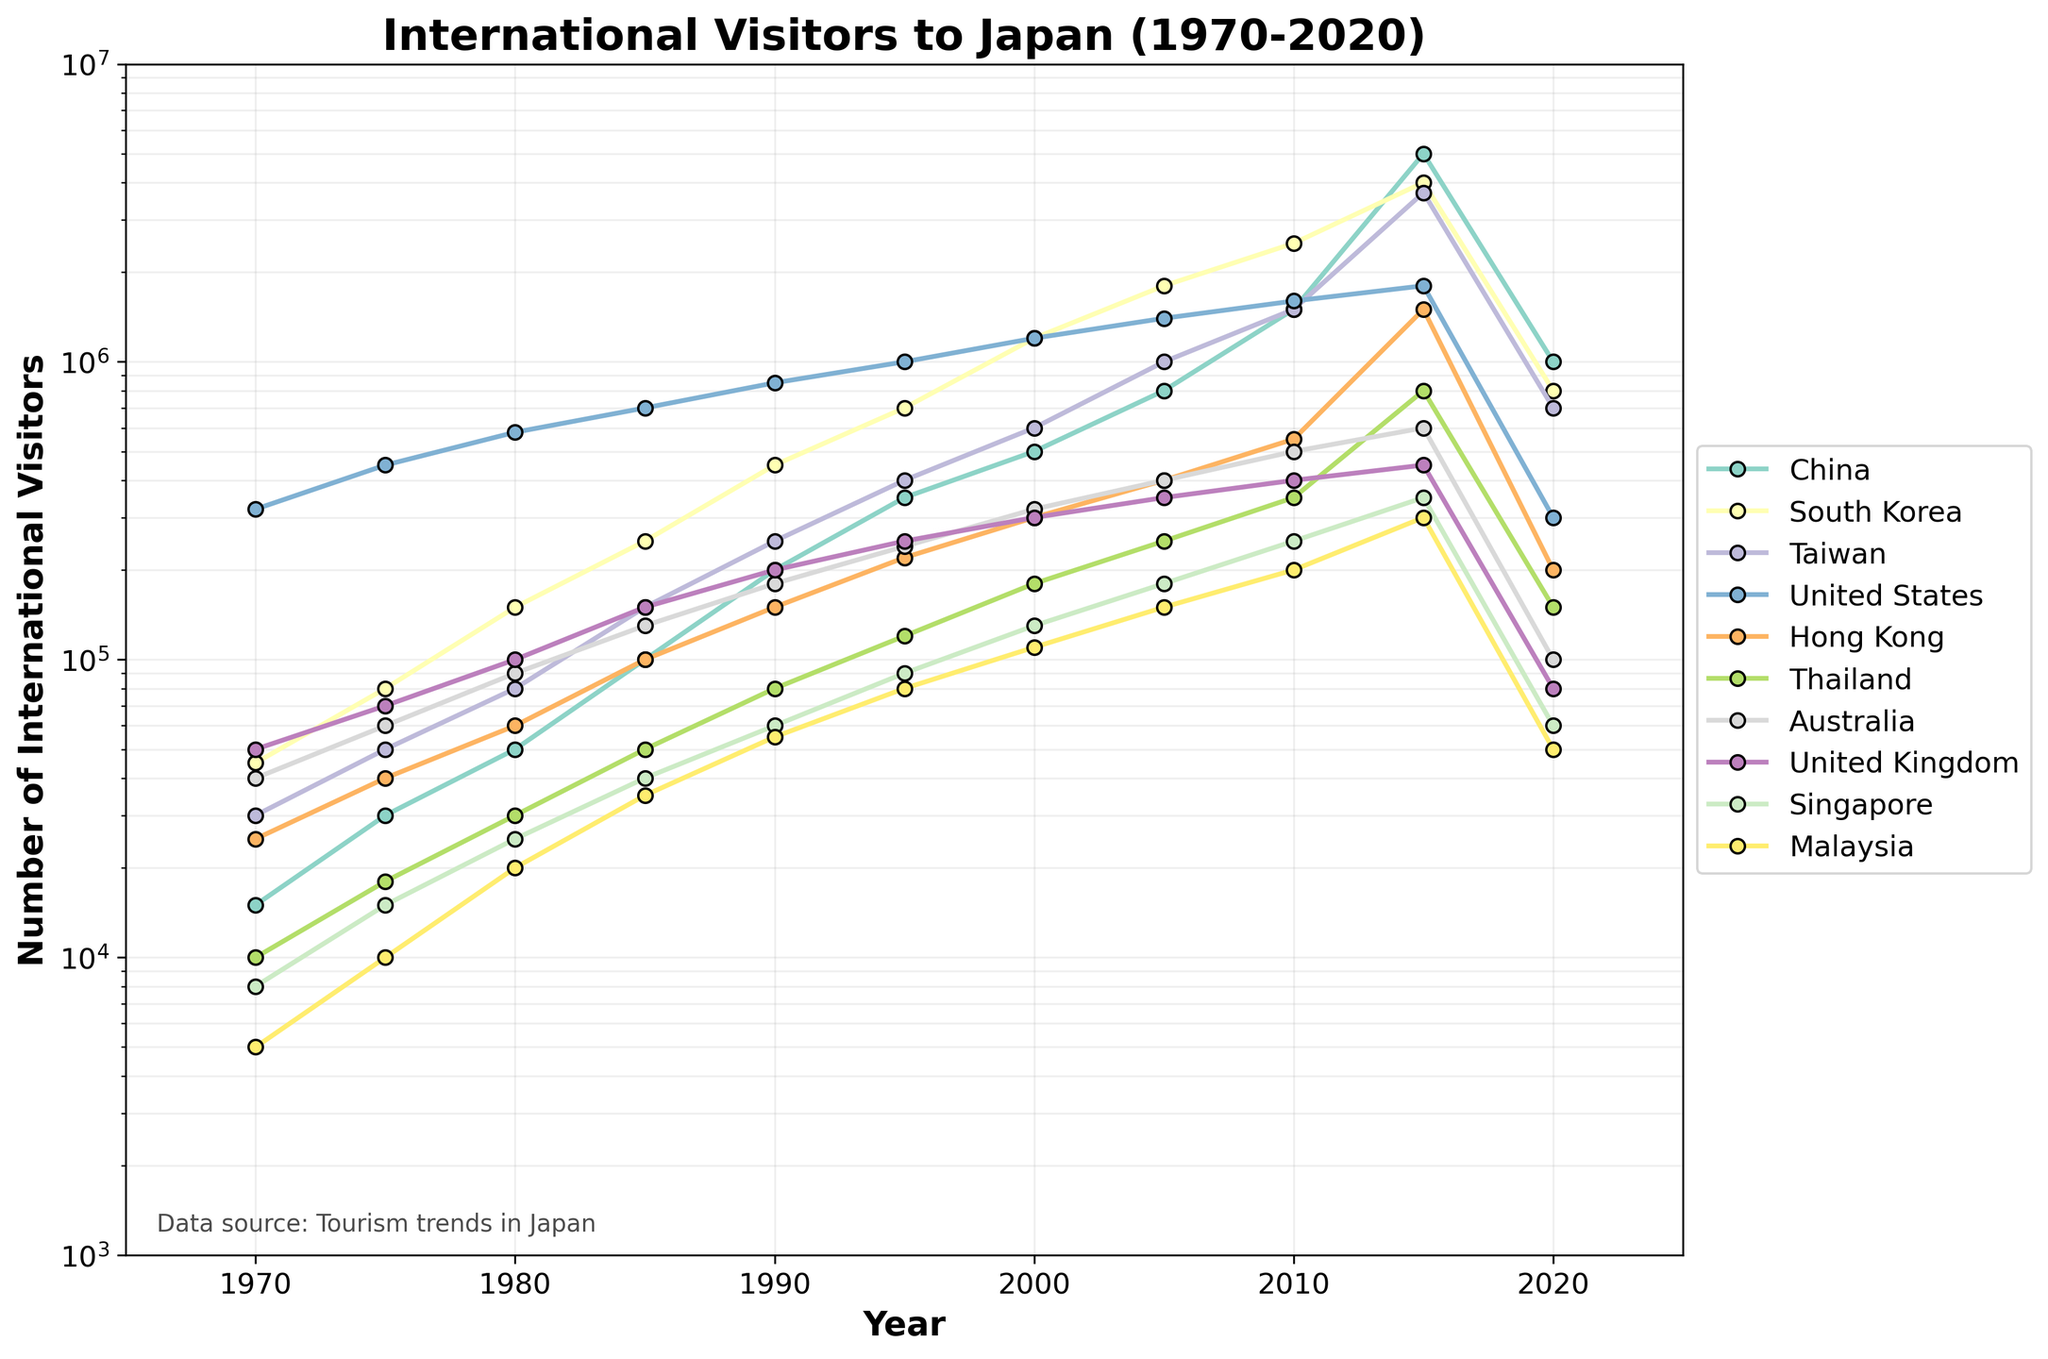What is the overall trend of the number of international visitors to Japan from China between 1970 and 2020? The trend for China's international visitors starts with a relatively low number in 1970, gradually increases until 2005, then exponentially increases to peak in 2015 followed by a drop in 2020.
Answer: Increasing, then a significant rise, and a drop Which country had the highest number of visitors to Japan in 2015? In 2015, the line for China reaches the highest point compared to other countries visible in the chart.
Answer: China How did the number of visitors from South Korea change between 2000 and 2010? The line representing South Korea’s visitors shows a notable increase from 1.2 million in 2000 to 2.5 million in 2010.
Answer: Increased by 1.3 million What is the difference in the number of visitors from the United States between 1990 and 2000? In 1990, the number of visitors from the United States is 850,000, and it increases to 1.2 million in 2000. The difference is 1,200,000 - 850,000.
Answer: 350,000 Which two countries had approximately the same number of visitors in 2010? In 2010, the lines for Taiwan and China intersect around the 1.5 million mark, indicating they had approximately the same number of visitors.
Answer: China and Taiwan How does the number of visitors from Australia in 1985 compare to those in 2005? In 1985, the number of visitors from Australia is 130,000 and in 2005 it is about 400,000. Subtracting the two values: 400,000 - 130,000.
Answer: 270,000 more Which country had the most significant decrease in visitors from 2015 to 2020? By examining the steepest decline in the lines between 2015 and 2020, China shows the most significant drop from 5 million to 1 million.
Answer: China How many visitors did the United Kingdom have in 1980 and what was its change by 2000? In 1980, the number of visitors from the United Kingdom is about 100,000, and by 2000, it increased to 300,000. The change is 300,000 - 100,000.
Answer: Increased by 200,000 Compute the average number of visitors from Taiwan between 1970 and 1995. The data for Taiwan in the specified years are 30,000, 50,000, 80,000, 150,000, 250,000, and 400,000. Adding these up: 30,000 + 50,000 + 80,000 + 150,000 + 250,000 + 400,000 results in 960,000. Dividing by 6 yields the average.
Answer: 160,000 Which country experienced a steady increase in visitors without any major drops or spikes? The line for the United States shows a steady increase from 1970 to 2005 without any noticeable drops or dramatic spikes.
Answer: United States 